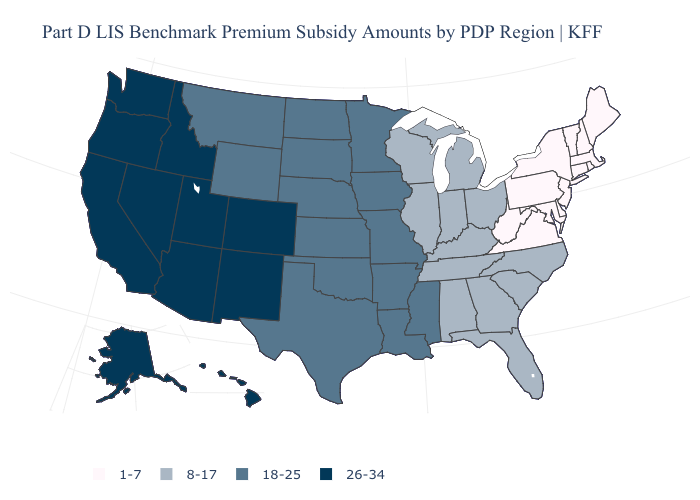What is the value of Nevada?
Short answer required. 26-34. What is the value of Mississippi?
Answer briefly. 18-25. Name the states that have a value in the range 18-25?
Quick response, please. Arkansas, Iowa, Kansas, Louisiana, Minnesota, Mississippi, Missouri, Montana, Nebraska, North Dakota, Oklahoma, South Dakota, Texas, Wyoming. Among the states that border Minnesota , which have the lowest value?
Be succinct. Wisconsin. Name the states that have a value in the range 18-25?
Answer briefly. Arkansas, Iowa, Kansas, Louisiana, Minnesota, Mississippi, Missouri, Montana, Nebraska, North Dakota, Oklahoma, South Dakota, Texas, Wyoming. What is the lowest value in the USA?
Give a very brief answer. 1-7. What is the value of Missouri?
Keep it brief. 18-25. Name the states that have a value in the range 1-7?
Be succinct. Connecticut, Delaware, Maine, Maryland, Massachusetts, New Hampshire, New Jersey, New York, Pennsylvania, Rhode Island, Vermont, Virginia, West Virginia. Name the states that have a value in the range 18-25?
Be succinct. Arkansas, Iowa, Kansas, Louisiana, Minnesota, Mississippi, Missouri, Montana, Nebraska, North Dakota, Oklahoma, South Dakota, Texas, Wyoming. Name the states that have a value in the range 18-25?
Write a very short answer. Arkansas, Iowa, Kansas, Louisiana, Minnesota, Mississippi, Missouri, Montana, Nebraska, North Dakota, Oklahoma, South Dakota, Texas, Wyoming. What is the highest value in the USA?
Short answer required. 26-34. Name the states that have a value in the range 1-7?
Answer briefly. Connecticut, Delaware, Maine, Maryland, Massachusetts, New Hampshire, New Jersey, New York, Pennsylvania, Rhode Island, Vermont, Virginia, West Virginia. What is the lowest value in the South?
Give a very brief answer. 1-7. Does the first symbol in the legend represent the smallest category?
Give a very brief answer. Yes. Name the states that have a value in the range 18-25?
Give a very brief answer. Arkansas, Iowa, Kansas, Louisiana, Minnesota, Mississippi, Missouri, Montana, Nebraska, North Dakota, Oklahoma, South Dakota, Texas, Wyoming. 